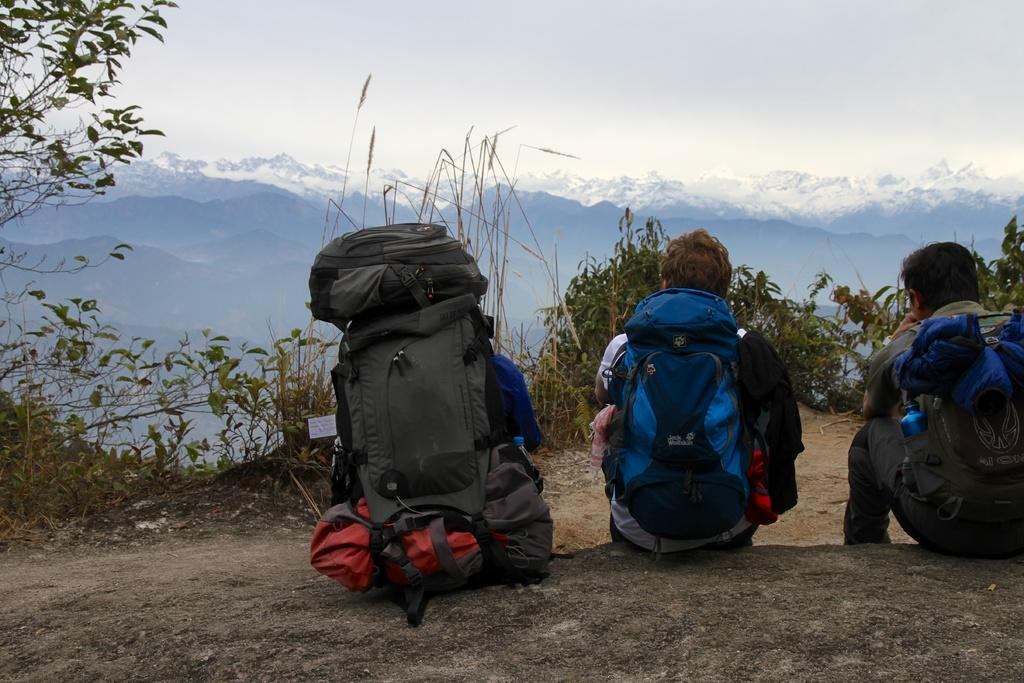Where is the location of the image? The image is outside of the city. How many people are in the image? There are three persons in the image. What can be seen in the background of the image? There are mountains visible in the background. What is visible in the sky in the image? There is a sky visible in the image. What type of vegetation is present on the left side of the image? There are plants present on the left side of the image. What is the name of the daughter of the person on the right side of the image? There is no daughter mentioned or visible in the image. How many times did the person in the middle of the image rest during the hike? The image does not provide information about the person's activities or rest periods during a hike. 